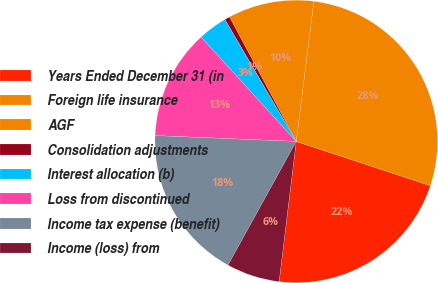Convert chart to OTSL. <chart><loc_0><loc_0><loc_500><loc_500><pie_chart><fcel>Years Ended December 31 (in<fcel>Foreign life insurance<fcel>AGF<fcel>Consolidation adjustments<fcel>Interest allocation (b)<fcel>Loss from discontinued<fcel>Income tax expense (benefit)<fcel>Income (loss) from<nl><fcel>21.86%<fcel>28.08%<fcel>9.83%<fcel>0.59%<fcel>3.34%<fcel>12.58%<fcel>17.64%<fcel>6.09%<nl></chart> 